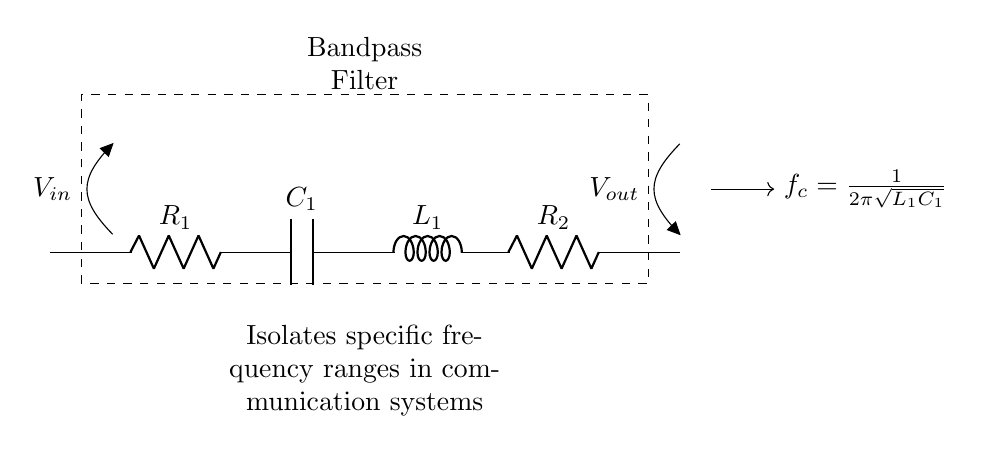What components are present in the circuit? The circuit consists of two resistors, a capacitor, and an inductor. Specifically, there are R1, R2, C1, and L1 present.
Answer: Resistors, capacitor, inductor What is the purpose of this circuit? The primary function of this bandpass filter is to isolate specific frequency ranges in communication systems. It allows certain frequencies to pass while attenuating others.
Answer: Isolate specific frequency ranges What are the voltage levels at the input and output? The input voltage is indicated as V-in and the output voltage as V-out. Without specific numerical values provided in the diagram, we cannot determine absolute values, only their labeling.
Answer: V-in, V-out What is the cut-off frequency of the bandpass filter? The cut-off frequency is determined by the formula given in the diagram, which is based on the values of the inductor and capacitor as f-c = 1/(2 * pi * sqrt(L1 * C1)).
Answer: 1/(2π√(L1C1)) How many energy storage elements are in this filter? The filter contains one inductor and one capacitor, which are both energy storage elements vital for filtering specific frequencies.
Answer: Two Why does the circuit isolate specific frequencies? The combination of resistors, inductor, and capacitor creates a resonance at a particular frequency, allowing that frequency to pass through while suppressing others, thus isolating specific frequencies.
Answer: Resonance at a specific frequency 